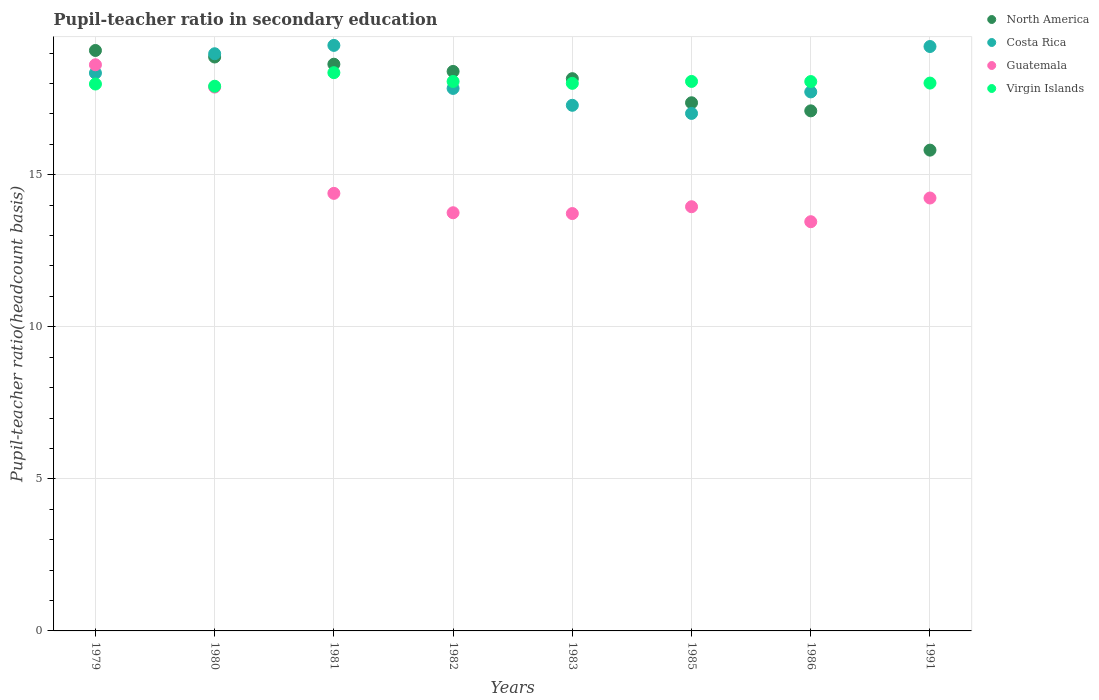Is the number of dotlines equal to the number of legend labels?
Make the answer very short. Yes. What is the pupil-teacher ratio in secondary education in Guatemala in 1979?
Your answer should be compact. 18.62. Across all years, what is the maximum pupil-teacher ratio in secondary education in North America?
Offer a terse response. 19.09. Across all years, what is the minimum pupil-teacher ratio in secondary education in North America?
Provide a succinct answer. 15.81. In which year was the pupil-teacher ratio in secondary education in Virgin Islands maximum?
Keep it short and to the point. 1981. In which year was the pupil-teacher ratio in secondary education in Costa Rica minimum?
Make the answer very short. 1985. What is the total pupil-teacher ratio in secondary education in North America in the graph?
Give a very brief answer. 143.43. What is the difference between the pupil-teacher ratio in secondary education in Guatemala in 1979 and that in 1980?
Your answer should be compact. 0.73. What is the difference between the pupil-teacher ratio in secondary education in Costa Rica in 1983 and the pupil-teacher ratio in secondary education in Guatemala in 1980?
Your answer should be very brief. -0.6. What is the average pupil-teacher ratio in secondary education in North America per year?
Offer a very short reply. 17.93. In the year 1991, what is the difference between the pupil-teacher ratio in secondary education in Virgin Islands and pupil-teacher ratio in secondary education in Guatemala?
Your answer should be very brief. 3.78. In how many years, is the pupil-teacher ratio in secondary education in Costa Rica greater than 10?
Your answer should be compact. 8. What is the ratio of the pupil-teacher ratio in secondary education in Costa Rica in 1980 to that in 1981?
Offer a very short reply. 0.99. Is the difference between the pupil-teacher ratio in secondary education in Virgin Islands in 1980 and 1983 greater than the difference between the pupil-teacher ratio in secondary education in Guatemala in 1980 and 1983?
Keep it short and to the point. No. What is the difference between the highest and the second highest pupil-teacher ratio in secondary education in North America?
Provide a succinct answer. 0.21. What is the difference between the highest and the lowest pupil-teacher ratio in secondary education in Costa Rica?
Give a very brief answer. 2.24. Is the sum of the pupil-teacher ratio in secondary education in Costa Rica in 1981 and 1991 greater than the maximum pupil-teacher ratio in secondary education in North America across all years?
Ensure brevity in your answer.  Yes. Is it the case that in every year, the sum of the pupil-teacher ratio in secondary education in Virgin Islands and pupil-teacher ratio in secondary education in Guatemala  is greater than the sum of pupil-teacher ratio in secondary education in North America and pupil-teacher ratio in secondary education in Costa Rica?
Your answer should be compact. No. Is the pupil-teacher ratio in secondary education in Guatemala strictly less than the pupil-teacher ratio in secondary education in Virgin Islands over the years?
Offer a very short reply. No. Does the graph contain any zero values?
Your response must be concise. No. Does the graph contain grids?
Provide a succinct answer. Yes. Where does the legend appear in the graph?
Make the answer very short. Top right. How are the legend labels stacked?
Provide a short and direct response. Vertical. What is the title of the graph?
Ensure brevity in your answer.  Pupil-teacher ratio in secondary education. Does "Guam" appear as one of the legend labels in the graph?
Keep it short and to the point. No. What is the label or title of the X-axis?
Ensure brevity in your answer.  Years. What is the label or title of the Y-axis?
Provide a short and direct response. Pupil-teacher ratio(headcount basis). What is the Pupil-teacher ratio(headcount basis) of North America in 1979?
Give a very brief answer. 19.09. What is the Pupil-teacher ratio(headcount basis) in Costa Rica in 1979?
Provide a short and direct response. 18.34. What is the Pupil-teacher ratio(headcount basis) of Guatemala in 1979?
Provide a short and direct response. 18.62. What is the Pupil-teacher ratio(headcount basis) of Virgin Islands in 1979?
Provide a short and direct response. 17.98. What is the Pupil-teacher ratio(headcount basis) of North America in 1980?
Provide a succinct answer. 18.87. What is the Pupil-teacher ratio(headcount basis) in Costa Rica in 1980?
Offer a terse response. 18.98. What is the Pupil-teacher ratio(headcount basis) of Guatemala in 1980?
Keep it short and to the point. 17.88. What is the Pupil-teacher ratio(headcount basis) in Virgin Islands in 1980?
Offer a very short reply. 17.91. What is the Pupil-teacher ratio(headcount basis) in North America in 1981?
Your answer should be compact. 18.63. What is the Pupil-teacher ratio(headcount basis) of Costa Rica in 1981?
Your response must be concise. 19.25. What is the Pupil-teacher ratio(headcount basis) of Guatemala in 1981?
Ensure brevity in your answer.  14.39. What is the Pupil-teacher ratio(headcount basis) of Virgin Islands in 1981?
Your response must be concise. 18.36. What is the Pupil-teacher ratio(headcount basis) in North America in 1982?
Give a very brief answer. 18.4. What is the Pupil-teacher ratio(headcount basis) of Costa Rica in 1982?
Provide a short and direct response. 17.84. What is the Pupil-teacher ratio(headcount basis) in Guatemala in 1982?
Your answer should be very brief. 13.75. What is the Pupil-teacher ratio(headcount basis) of Virgin Islands in 1982?
Your answer should be very brief. 18.07. What is the Pupil-teacher ratio(headcount basis) in North America in 1983?
Your answer should be very brief. 18.16. What is the Pupil-teacher ratio(headcount basis) in Costa Rica in 1983?
Offer a terse response. 17.28. What is the Pupil-teacher ratio(headcount basis) in Guatemala in 1983?
Provide a succinct answer. 13.72. What is the Pupil-teacher ratio(headcount basis) in Virgin Islands in 1983?
Offer a terse response. 18.01. What is the Pupil-teacher ratio(headcount basis) in North America in 1985?
Make the answer very short. 17.37. What is the Pupil-teacher ratio(headcount basis) of Costa Rica in 1985?
Your response must be concise. 17.02. What is the Pupil-teacher ratio(headcount basis) of Guatemala in 1985?
Your answer should be compact. 13.95. What is the Pupil-teacher ratio(headcount basis) in Virgin Islands in 1985?
Your response must be concise. 18.07. What is the Pupil-teacher ratio(headcount basis) in North America in 1986?
Ensure brevity in your answer.  17.1. What is the Pupil-teacher ratio(headcount basis) in Costa Rica in 1986?
Offer a very short reply. 17.72. What is the Pupil-teacher ratio(headcount basis) in Guatemala in 1986?
Your answer should be compact. 13.46. What is the Pupil-teacher ratio(headcount basis) of Virgin Islands in 1986?
Provide a short and direct response. 18.06. What is the Pupil-teacher ratio(headcount basis) in North America in 1991?
Keep it short and to the point. 15.81. What is the Pupil-teacher ratio(headcount basis) of Costa Rica in 1991?
Your answer should be compact. 19.22. What is the Pupil-teacher ratio(headcount basis) in Guatemala in 1991?
Provide a succinct answer. 14.24. What is the Pupil-teacher ratio(headcount basis) in Virgin Islands in 1991?
Provide a succinct answer. 18.01. Across all years, what is the maximum Pupil-teacher ratio(headcount basis) in North America?
Provide a succinct answer. 19.09. Across all years, what is the maximum Pupil-teacher ratio(headcount basis) in Costa Rica?
Ensure brevity in your answer.  19.25. Across all years, what is the maximum Pupil-teacher ratio(headcount basis) in Guatemala?
Provide a succinct answer. 18.62. Across all years, what is the maximum Pupil-teacher ratio(headcount basis) of Virgin Islands?
Make the answer very short. 18.36. Across all years, what is the minimum Pupil-teacher ratio(headcount basis) of North America?
Keep it short and to the point. 15.81. Across all years, what is the minimum Pupil-teacher ratio(headcount basis) in Costa Rica?
Keep it short and to the point. 17.02. Across all years, what is the minimum Pupil-teacher ratio(headcount basis) of Guatemala?
Give a very brief answer. 13.46. Across all years, what is the minimum Pupil-teacher ratio(headcount basis) of Virgin Islands?
Keep it short and to the point. 17.91. What is the total Pupil-teacher ratio(headcount basis) of North America in the graph?
Make the answer very short. 143.43. What is the total Pupil-teacher ratio(headcount basis) of Costa Rica in the graph?
Make the answer very short. 145.66. What is the total Pupil-teacher ratio(headcount basis) of Guatemala in the graph?
Offer a terse response. 120. What is the total Pupil-teacher ratio(headcount basis) in Virgin Islands in the graph?
Keep it short and to the point. 144.47. What is the difference between the Pupil-teacher ratio(headcount basis) of North America in 1979 and that in 1980?
Your response must be concise. 0.21. What is the difference between the Pupil-teacher ratio(headcount basis) of Costa Rica in 1979 and that in 1980?
Provide a succinct answer. -0.63. What is the difference between the Pupil-teacher ratio(headcount basis) of Guatemala in 1979 and that in 1980?
Provide a succinct answer. 0.73. What is the difference between the Pupil-teacher ratio(headcount basis) in Virgin Islands in 1979 and that in 1980?
Provide a short and direct response. 0.07. What is the difference between the Pupil-teacher ratio(headcount basis) in North America in 1979 and that in 1981?
Offer a terse response. 0.45. What is the difference between the Pupil-teacher ratio(headcount basis) of Costa Rica in 1979 and that in 1981?
Offer a very short reply. -0.91. What is the difference between the Pupil-teacher ratio(headcount basis) in Guatemala in 1979 and that in 1981?
Keep it short and to the point. 4.23. What is the difference between the Pupil-teacher ratio(headcount basis) of Virgin Islands in 1979 and that in 1981?
Your answer should be very brief. -0.37. What is the difference between the Pupil-teacher ratio(headcount basis) in North America in 1979 and that in 1982?
Your answer should be very brief. 0.69. What is the difference between the Pupil-teacher ratio(headcount basis) of Costa Rica in 1979 and that in 1982?
Your response must be concise. 0.51. What is the difference between the Pupil-teacher ratio(headcount basis) in Guatemala in 1979 and that in 1982?
Keep it short and to the point. 4.87. What is the difference between the Pupil-teacher ratio(headcount basis) in Virgin Islands in 1979 and that in 1982?
Make the answer very short. -0.08. What is the difference between the Pupil-teacher ratio(headcount basis) of North America in 1979 and that in 1983?
Offer a terse response. 0.93. What is the difference between the Pupil-teacher ratio(headcount basis) in Costa Rica in 1979 and that in 1983?
Make the answer very short. 1.06. What is the difference between the Pupil-teacher ratio(headcount basis) of Guatemala in 1979 and that in 1983?
Offer a terse response. 4.89. What is the difference between the Pupil-teacher ratio(headcount basis) of Virgin Islands in 1979 and that in 1983?
Keep it short and to the point. -0.02. What is the difference between the Pupil-teacher ratio(headcount basis) in North America in 1979 and that in 1985?
Your answer should be very brief. 1.72. What is the difference between the Pupil-teacher ratio(headcount basis) of Costa Rica in 1979 and that in 1985?
Give a very brief answer. 1.33. What is the difference between the Pupil-teacher ratio(headcount basis) of Guatemala in 1979 and that in 1985?
Provide a short and direct response. 4.67. What is the difference between the Pupil-teacher ratio(headcount basis) of Virgin Islands in 1979 and that in 1985?
Provide a short and direct response. -0.09. What is the difference between the Pupil-teacher ratio(headcount basis) of North America in 1979 and that in 1986?
Offer a terse response. 1.99. What is the difference between the Pupil-teacher ratio(headcount basis) of Costa Rica in 1979 and that in 1986?
Offer a very short reply. 0.62. What is the difference between the Pupil-teacher ratio(headcount basis) in Guatemala in 1979 and that in 1986?
Provide a succinct answer. 5.16. What is the difference between the Pupil-teacher ratio(headcount basis) in Virgin Islands in 1979 and that in 1986?
Your answer should be very brief. -0.08. What is the difference between the Pupil-teacher ratio(headcount basis) of North America in 1979 and that in 1991?
Ensure brevity in your answer.  3.28. What is the difference between the Pupil-teacher ratio(headcount basis) in Costa Rica in 1979 and that in 1991?
Ensure brevity in your answer.  -0.87. What is the difference between the Pupil-teacher ratio(headcount basis) of Guatemala in 1979 and that in 1991?
Make the answer very short. 4.38. What is the difference between the Pupil-teacher ratio(headcount basis) in Virgin Islands in 1979 and that in 1991?
Your answer should be compact. -0.03. What is the difference between the Pupil-teacher ratio(headcount basis) of North America in 1980 and that in 1981?
Provide a short and direct response. 0.24. What is the difference between the Pupil-teacher ratio(headcount basis) of Costa Rica in 1980 and that in 1981?
Ensure brevity in your answer.  -0.28. What is the difference between the Pupil-teacher ratio(headcount basis) in Guatemala in 1980 and that in 1981?
Your response must be concise. 3.49. What is the difference between the Pupil-teacher ratio(headcount basis) in Virgin Islands in 1980 and that in 1981?
Make the answer very short. -0.45. What is the difference between the Pupil-teacher ratio(headcount basis) in North America in 1980 and that in 1982?
Your answer should be compact. 0.47. What is the difference between the Pupil-teacher ratio(headcount basis) of Costa Rica in 1980 and that in 1982?
Keep it short and to the point. 1.14. What is the difference between the Pupil-teacher ratio(headcount basis) of Guatemala in 1980 and that in 1982?
Make the answer very short. 4.13. What is the difference between the Pupil-teacher ratio(headcount basis) of Virgin Islands in 1980 and that in 1982?
Keep it short and to the point. -0.16. What is the difference between the Pupil-teacher ratio(headcount basis) of North America in 1980 and that in 1983?
Offer a very short reply. 0.71. What is the difference between the Pupil-teacher ratio(headcount basis) in Costa Rica in 1980 and that in 1983?
Make the answer very short. 1.69. What is the difference between the Pupil-teacher ratio(headcount basis) of Guatemala in 1980 and that in 1983?
Your answer should be very brief. 4.16. What is the difference between the Pupil-teacher ratio(headcount basis) in Virgin Islands in 1980 and that in 1983?
Keep it short and to the point. -0.09. What is the difference between the Pupil-teacher ratio(headcount basis) of North America in 1980 and that in 1985?
Make the answer very short. 1.5. What is the difference between the Pupil-teacher ratio(headcount basis) in Costa Rica in 1980 and that in 1985?
Your answer should be very brief. 1.96. What is the difference between the Pupil-teacher ratio(headcount basis) of Guatemala in 1980 and that in 1985?
Your answer should be compact. 3.93. What is the difference between the Pupil-teacher ratio(headcount basis) of Virgin Islands in 1980 and that in 1985?
Give a very brief answer. -0.16. What is the difference between the Pupil-teacher ratio(headcount basis) of North America in 1980 and that in 1986?
Offer a very short reply. 1.77. What is the difference between the Pupil-teacher ratio(headcount basis) in Costa Rica in 1980 and that in 1986?
Keep it short and to the point. 1.25. What is the difference between the Pupil-teacher ratio(headcount basis) of Guatemala in 1980 and that in 1986?
Your answer should be compact. 4.43. What is the difference between the Pupil-teacher ratio(headcount basis) of Virgin Islands in 1980 and that in 1986?
Give a very brief answer. -0.15. What is the difference between the Pupil-teacher ratio(headcount basis) of North America in 1980 and that in 1991?
Offer a terse response. 3.06. What is the difference between the Pupil-teacher ratio(headcount basis) of Costa Rica in 1980 and that in 1991?
Provide a short and direct response. -0.24. What is the difference between the Pupil-teacher ratio(headcount basis) in Guatemala in 1980 and that in 1991?
Your answer should be very brief. 3.65. What is the difference between the Pupil-teacher ratio(headcount basis) in Virgin Islands in 1980 and that in 1991?
Ensure brevity in your answer.  -0.1. What is the difference between the Pupil-teacher ratio(headcount basis) of North America in 1981 and that in 1982?
Provide a succinct answer. 0.24. What is the difference between the Pupil-teacher ratio(headcount basis) of Costa Rica in 1981 and that in 1982?
Give a very brief answer. 1.42. What is the difference between the Pupil-teacher ratio(headcount basis) in Guatemala in 1981 and that in 1982?
Your answer should be compact. 0.64. What is the difference between the Pupil-teacher ratio(headcount basis) in Virgin Islands in 1981 and that in 1982?
Your answer should be compact. 0.29. What is the difference between the Pupil-teacher ratio(headcount basis) in North America in 1981 and that in 1983?
Make the answer very short. 0.48. What is the difference between the Pupil-teacher ratio(headcount basis) in Costa Rica in 1981 and that in 1983?
Your answer should be compact. 1.97. What is the difference between the Pupil-teacher ratio(headcount basis) of Guatemala in 1981 and that in 1983?
Ensure brevity in your answer.  0.66. What is the difference between the Pupil-teacher ratio(headcount basis) in Virgin Islands in 1981 and that in 1983?
Offer a terse response. 0.35. What is the difference between the Pupil-teacher ratio(headcount basis) of North America in 1981 and that in 1985?
Your answer should be compact. 1.27. What is the difference between the Pupil-teacher ratio(headcount basis) of Costa Rica in 1981 and that in 1985?
Keep it short and to the point. 2.24. What is the difference between the Pupil-teacher ratio(headcount basis) in Guatemala in 1981 and that in 1985?
Offer a very short reply. 0.44. What is the difference between the Pupil-teacher ratio(headcount basis) in Virgin Islands in 1981 and that in 1985?
Provide a succinct answer. 0.29. What is the difference between the Pupil-teacher ratio(headcount basis) of North America in 1981 and that in 1986?
Keep it short and to the point. 1.53. What is the difference between the Pupil-teacher ratio(headcount basis) in Costa Rica in 1981 and that in 1986?
Give a very brief answer. 1.53. What is the difference between the Pupil-teacher ratio(headcount basis) of Guatemala in 1981 and that in 1986?
Provide a short and direct response. 0.93. What is the difference between the Pupil-teacher ratio(headcount basis) in Virgin Islands in 1981 and that in 1986?
Keep it short and to the point. 0.29. What is the difference between the Pupil-teacher ratio(headcount basis) of North America in 1981 and that in 1991?
Offer a very short reply. 2.83. What is the difference between the Pupil-teacher ratio(headcount basis) in Costa Rica in 1981 and that in 1991?
Your answer should be very brief. 0.04. What is the difference between the Pupil-teacher ratio(headcount basis) of Guatemala in 1981 and that in 1991?
Make the answer very short. 0.15. What is the difference between the Pupil-teacher ratio(headcount basis) of Virgin Islands in 1981 and that in 1991?
Keep it short and to the point. 0.34. What is the difference between the Pupil-teacher ratio(headcount basis) of North America in 1982 and that in 1983?
Your answer should be very brief. 0.24. What is the difference between the Pupil-teacher ratio(headcount basis) in Costa Rica in 1982 and that in 1983?
Your answer should be compact. 0.55. What is the difference between the Pupil-teacher ratio(headcount basis) of Guatemala in 1982 and that in 1983?
Provide a short and direct response. 0.03. What is the difference between the Pupil-teacher ratio(headcount basis) of Virgin Islands in 1982 and that in 1983?
Offer a terse response. 0.06. What is the difference between the Pupil-teacher ratio(headcount basis) of North America in 1982 and that in 1985?
Make the answer very short. 1.03. What is the difference between the Pupil-teacher ratio(headcount basis) in Costa Rica in 1982 and that in 1985?
Your answer should be compact. 0.82. What is the difference between the Pupil-teacher ratio(headcount basis) of Guatemala in 1982 and that in 1985?
Give a very brief answer. -0.2. What is the difference between the Pupil-teacher ratio(headcount basis) in Virgin Islands in 1982 and that in 1985?
Your answer should be very brief. -0. What is the difference between the Pupil-teacher ratio(headcount basis) of North America in 1982 and that in 1986?
Ensure brevity in your answer.  1.3. What is the difference between the Pupil-teacher ratio(headcount basis) in Costa Rica in 1982 and that in 1986?
Offer a very short reply. 0.11. What is the difference between the Pupil-teacher ratio(headcount basis) of Guatemala in 1982 and that in 1986?
Your answer should be very brief. 0.29. What is the difference between the Pupil-teacher ratio(headcount basis) in Virgin Islands in 1982 and that in 1986?
Keep it short and to the point. 0. What is the difference between the Pupil-teacher ratio(headcount basis) of North America in 1982 and that in 1991?
Ensure brevity in your answer.  2.59. What is the difference between the Pupil-teacher ratio(headcount basis) in Costa Rica in 1982 and that in 1991?
Your response must be concise. -1.38. What is the difference between the Pupil-teacher ratio(headcount basis) in Guatemala in 1982 and that in 1991?
Your answer should be compact. -0.48. What is the difference between the Pupil-teacher ratio(headcount basis) of Virgin Islands in 1982 and that in 1991?
Offer a very short reply. 0.05. What is the difference between the Pupil-teacher ratio(headcount basis) of North America in 1983 and that in 1985?
Provide a short and direct response. 0.79. What is the difference between the Pupil-teacher ratio(headcount basis) in Costa Rica in 1983 and that in 1985?
Keep it short and to the point. 0.27. What is the difference between the Pupil-teacher ratio(headcount basis) in Guatemala in 1983 and that in 1985?
Ensure brevity in your answer.  -0.22. What is the difference between the Pupil-teacher ratio(headcount basis) in Virgin Islands in 1983 and that in 1985?
Keep it short and to the point. -0.06. What is the difference between the Pupil-teacher ratio(headcount basis) of North America in 1983 and that in 1986?
Your response must be concise. 1.06. What is the difference between the Pupil-teacher ratio(headcount basis) in Costa Rica in 1983 and that in 1986?
Your answer should be compact. -0.44. What is the difference between the Pupil-teacher ratio(headcount basis) in Guatemala in 1983 and that in 1986?
Make the answer very short. 0.27. What is the difference between the Pupil-teacher ratio(headcount basis) of Virgin Islands in 1983 and that in 1986?
Your answer should be compact. -0.06. What is the difference between the Pupil-teacher ratio(headcount basis) in North America in 1983 and that in 1991?
Provide a succinct answer. 2.35. What is the difference between the Pupil-teacher ratio(headcount basis) in Costa Rica in 1983 and that in 1991?
Provide a short and direct response. -1.93. What is the difference between the Pupil-teacher ratio(headcount basis) in Guatemala in 1983 and that in 1991?
Offer a terse response. -0.51. What is the difference between the Pupil-teacher ratio(headcount basis) of Virgin Islands in 1983 and that in 1991?
Provide a short and direct response. -0.01. What is the difference between the Pupil-teacher ratio(headcount basis) of North America in 1985 and that in 1986?
Make the answer very short. 0.27. What is the difference between the Pupil-teacher ratio(headcount basis) in Costa Rica in 1985 and that in 1986?
Your response must be concise. -0.71. What is the difference between the Pupil-teacher ratio(headcount basis) of Guatemala in 1985 and that in 1986?
Offer a terse response. 0.49. What is the difference between the Pupil-teacher ratio(headcount basis) in Virgin Islands in 1985 and that in 1986?
Offer a very short reply. 0. What is the difference between the Pupil-teacher ratio(headcount basis) in North America in 1985 and that in 1991?
Make the answer very short. 1.56. What is the difference between the Pupil-teacher ratio(headcount basis) of Costa Rica in 1985 and that in 1991?
Give a very brief answer. -2.2. What is the difference between the Pupil-teacher ratio(headcount basis) in Guatemala in 1985 and that in 1991?
Offer a very short reply. -0.29. What is the difference between the Pupil-teacher ratio(headcount basis) of Virgin Islands in 1985 and that in 1991?
Offer a very short reply. 0.05. What is the difference between the Pupil-teacher ratio(headcount basis) of North America in 1986 and that in 1991?
Ensure brevity in your answer.  1.29. What is the difference between the Pupil-teacher ratio(headcount basis) in Costa Rica in 1986 and that in 1991?
Your answer should be compact. -1.49. What is the difference between the Pupil-teacher ratio(headcount basis) of Guatemala in 1986 and that in 1991?
Your answer should be very brief. -0.78. What is the difference between the Pupil-teacher ratio(headcount basis) of Virgin Islands in 1986 and that in 1991?
Your response must be concise. 0.05. What is the difference between the Pupil-teacher ratio(headcount basis) of North America in 1979 and the Pupil-teacher ratio(headcount basis) of Costa Rica in 1980?
Provide a short and direct response. 0.11. What is the difference between the Pupil-teacher ratio(headcount basis) in North America in 1979 and the Pupil-teacher ratio(headcount basis) in Guatemala in 1980?
Keep it short and to the point. 1.2. What is the difference between the Pupil-teacher ratio(headcount basis) in North America in 1979 and the Pupil-teacher ratio(headcount basis) in Virgin Islands in 1980?
Give a very brief answer. 1.18. What is the difference between the Pupil-teacher ratio(headcount basis) in Costa Rica in 1979 and the Pupil-teacher ratio(headcount basis) in Guatemala in 1980?
Offer a very short reply. 0.46. What is the difference between the Pupil-teacher ratio(headcount basis) of Costa Rica in 1979 and the Pupil-teacher ratio(headcount basis) of Virgin Islands in 1980?
Ensure brevity in your answer.  0.43. What is the difference between the Pupil-teacher ratio(headcount basis) in Guatemala in 1979 and the Pupil-teacher ratio(headcount basis) in Virgin Islands in 1980?
Ensure brevity in your answer.  0.71. What is the difference between the Pupil-teacher ratio(headcount basis) of North America in 1979 and the Pupil-teacher ratio(headcount basis) of Costa Rica in 1981?
Offer a very short reply. -0.17. What is the difference between the Pupil-teacher ratio(headcount basis) of North America in 1979 and the Pupil-teacher ratio(headcount basis) of Guatemala in 1981?
Give a very brief answer. 4.7. What is the difference between the Pupil-teacher ratio(headcount basis) in North America in 1979 and the Pupil-teacher ratio(headcount basis) in Virgin Islands in 1981?
Provide a short and direct response. 0.73. What is the difference between the Pupil-teacher ratio(headcount basis) of Costa Rica in 1979 and the Pupil-teacher ratio(headcount basis) of Guatemala in 1981?
Provide a succinct answer. 3.96. What is the difference between the Pupil-teacher ratio(headcount basis) in Costa Rica in 1979 and the Pupil-teacher ratio(headcount basis) in Virgin Islands in 1981?
Provide a succinct answer. -0.01. What is the difference between the Pupil-teacher ratio(headcount basis) in Guatemala in 1979 and the Pupil-teacher ratio(headcount basis) in Virgin Islands in 1981?
Your answer should be compact. 0.26. What is the difference between the Pupil-teacher ratio(headcount basis) in North America in 1979 and the Pupil-teacher ratio(headcount basis) in Costa Rica in 1982?
Make the answer very short. 1.25. What is the difference between the Pupil-teacher ratio(headcount basis) in North America in 1979 and the Pupil-teacher ratio(headcount basis) in Guatemala in 1982?
Make the answer very short. 5.34. What is the difference between the Pupil-teacher ratio(headcount basis) in Costa Rica in 1979 and the Pupil-teacher ratio(headcount basis) in Guatemala in 1982?
Make the answer very short. 4.59. What is the difference between the Pupil-teacher ratio(headcount basis) of Costa Rica in 1979 and the Pupil-teacher ratio(headcount basis) of Virgin Islands in 1982?
Make the answer very short. 0.28. What is the difference between the Pupil-teacher ratio(headcount basis) of Guatemala in 1979 and the Pupil-teacher ratio(headcount basis) of Virgin Islands in 1982?
Your response must be concise. 0.55. What is the difference between the Pupil-teacher ratio(headcount basis) of North America in 1979 and the Pupil-teacher ratio(headcount basis) of Costa Rica in 1983?
Give a very brief answer. 1.8. What is the difference between the Pupil-teacher ratio(headcount basis) of North America in 1979 and the Pupil-teacher ratio(headcount basis) of Guatemala in 1983?
Your answer should be very brief. 5.36. What is the difference between the Pupil-teacher ratio(headcount basis) of North America in 1979 and the Pupil-teacher ratio(headcount basis) of Virgin Islands in 1983?
Offer a terse response. 1.08. What is the difference between the Pupil-teacher ratio(headcount basis) in Costa Rica in 1979 and the Pupil-teacher ratio(headcount basis) in Guatemala in 1983?
Your answer should be compact. 4.62. What is the difference between the Pupil-teacher ratio(headcount basis) in Costa Rica in 1979 and the Pupil-teacher ratio(headcount basis) in Virgin Islands in 1983?
Offer a very short reply. 0.34. What is the difference between the Pupil-teacher ratio(headcount basis) of Guatemala in 1979 and the Pupil-teacher ratio(headcount basis) of Virgin Islands in 1983?
Offer a terse response. 0.61. What is the difference between the Pupil-teacher ratio(headcount basis) of North America in 1979 and the Pupil-teacher ratio(headcount basis) of Costa Rica in 1985?
Offer a terse response. 2.07. What is the difference between the Pupil-teacher ratio(headcount basis) of North America in 1979 and the Pupil-teacher ratio(headcount basis) of Guatemala in 1985?
Offer a terse response. 5.14. What is the difference between the Pupil-teacher ratio(headcount basis) in North America in 1979 and the Pupil-teacher ratio(headcount basis) in Virgin Islands in 1985?
Your answer should be very brief. 1.02. What is the difference between the Pupil-teacher ratio(headcount basis) of Costa Rica in 1979 and the Pupil-teacher ratio(headcount basis) of Guatemala in 1985?
Provide a succinct answer. 4.4. What is the difference between the Pupil-teacher ratio(headcount basis) in Costa Rica in 1979 and the Pupil-teacher ratio(headcount basis) in Virgin Islands in 1985?
Give a very brief answer. 0.28. What is the difference between the Pupil-teacher ratio(headcount basis) of Guatemala in 1979 and the Pupil-teacher ratio(headcount basis) of Virgin Islands in 1985?
Make the answer very short. 0.55. What is the difference between the Pupil-teacher ratio(headcount basis) of North America in 1979 and the Pupil-teacher ratio(headcount basis) of Costa Rica in 1986?
Your answer should be compact. 1.36. What is the difference between the Pupil-teacher ratio(headcount basis) in North America in 1979 and the Pupil-teacher ratio(headcount basis) in Guatemala in 1986?
Provide a short and direct response. 5.63. What is the difference between the Pupil-teacher ratio(headcount basis) of North America in 1979 and the Pupil-teacher ratio(headcount basis) of Virgin Islands in 1986?
Your answer should be very brief. 1.02. What is the difference between the Pupil-teacher ratio(headcount basis) in Costa Rica in 1979 and the Pupil-teacher ratio(headcount basis) in Guatemala in 1986?
Your response must be concise. 4.89. What is the difference between the Pupil-teacher ratio(headcount basis) in Costa Rica in 1979 and the Pupil-teacher ratio(headcount basis) in Virgin Islands in 1986?
Your answer should be compact. 0.28. What is the difference between the Pupil-teacher ratio(headcount basis) in Guatemala in 1979 and the Pupil-teacher ratio(headcount basis) in Virgin Islands in 1986?
Your answer should be very brief. 0.55. What is the difference between the Pupil-teacher ratio(headcount basis) of North America in 1979 and the Pupil-teacher ratio(headcount basis) of Costa Rica in 1991?
Your response must be concise. -0.13. What is the difference between the Pupil-teacher ratio(headcount basis) of North America in 1979 and the Pupil-teacher ratio(headcount basis) of Guatemala in 1991?
Your answer should be very brief. 4.85. What is the difference between the Pupil-teacher ratio(headcount basis) of North America in 1979 and the Pupil-teacher ratio(headcount basis) of Virgin Islands in 1991?
Ensure brevity in your answer.  1.07. What is the difference between the Pupil-teacher ratio(headcount basis) of Costa Rica in 1979 and the Pupil-teacher ratio(headcount basis) of Guatemala in 1991?
Your answer should be very brief. 4.11. What is the difference between the Pupil-teacher ratio(headcount basis) in Costa Rica in 1979 and the Pupil-teacher ratio(headcount basis) in Virgin Islands in 1991?
Your answer should be very brief. 0.33. What is the difference between the Pupil-teacher ratio(headcount basis) of Guatemala in 1979 and the Pupil-teacher ratio(headcount basis) of Virgin Islands in 1991?
Provide a short and direct response. 0.6. What is the difference between the Pupil-teacher ratio(headcount basis) of North America in 1980 and the Pupil-teacher ratio(headcount basis) of Costa Rica in 1981?
Your response must be concise. -0.38. What is the difference between the Pupil-teacher ratio(headcount basis) in North America in 1980 and the Pupil-teacher ratio(headcount basis) in Guatemala in 1981?
Make the answer very short. 4.48. What is the difference between the Pupil-teacher ratio(headcount basis) of North America in 1980 and the Pupil-teacher ratio(headcount basis) of Virgin Islands in 1981?
Your answer should be compact. 0.52. What is the difference between the Pupil-teacher ratio(headcount basis) of Costa Rica in 1980 and the Pupil-teacher ratio(headcount basis) of Guatemala in 1981?
Offer a very short reply. 4.59. What is the difference between the Pupil-teacher ratio(headcount basis) of Costa Rica in 1980 and the Pupil-teacher ratio(headcount basis) of Virgin Islands in 1981?
Ensure brevity in your answer.  0.62. What is the difference between the Pupil-teacher ratio(headcount basis) of Guatemala in 1980 and the Pupil-teacher ratio(headcount basis) of Virgin Islands in 1981?
Provide a short and direct response. -0.47. What is the difference between the Pupil-teacher ratio(headcount basis) in North America in 1980 and the Pupil-teacher ratio(headcount basis) in Costa Rica in 1982?
Give a very brief answer. 1.03. What is the difference between the Pupil-teacher ratio(headcount basis) in North America in 1980 and the Pupil-teacher ratio(headcount basis) in Guatemala in 1982?
Give a very brief answer. 5.12. What is the difference between the Pupil-teacher ratio(headcount basis) in North America in 1980 and the Pupil-teacher ratio(headcount basis) in Virgin Islands in 1982?
Give a very brief answer. 0.8. What is the difference between the Pupil-teacher ratio(headcount basis) in Costa Rica in 1980 and the Pupil-teacher ratio(headcount basis) in Guatemala in 1982?
Offer a very short reply. 5.23. What is the difference between the Pupil-teacher ratio(headcount basis) in Costa Rica in 1980 and the Pupil-teacher ratio(headcount basis) in Virgin Islands in 1982?
Your answer should be very brief. 0.91. What is the difference between the Pupil-teacher ratio(headcount basis) in Guatemala in 1980 and the Pupil-teacher ratio(headcount basis) in Virgin Islands in 1982?
Your answer should be very brief. -0.19. What is the difference between the Pupil-teacher ratio(headcount basis) of North America in 1980 and the Pupil-teacher ratio(headcount basis) of Costa Rica in 1983?
Keep it short and to the point. 1.59. What is the difference between the Pupil-teacher ratio(headcount basis) of North America in 1980 and the Pupil-teacher ratio(headcount basis) of Guatemala in 1983?
Keep it short and to the point. 5.15. What is the difference between the Pupil-teacher ratio(headcount basis) of North America in 1980 and the Pupil-teacher ratio(headcount basis) of Virgin Islands in 1983?
Make the answer very short. 0.87. What is the difference between the Pupil-teacher ratio(headcount basis) in Costa Rica in 1980 and the Pupil-teacher ratio(headcount basis) in Guatemala in 1983?
Offer a very short reply. 5.25. What is the difference between the Pupil-teacher ratio(headcount basis) in Costa Rica in 1980 and the Pupil-teacher ratio(headcount basis) in Virgin Islands in 1983?
Your answer should be very brief. 0.97. What is the difference between the Pupil-teacher ratio(headcount basis) in Guatemala in 1980 and the Pupil-teacher ratio(headcount basis) in Virgin Islands in 1983?
Your answer should be very brief. -0.12. What is the difference between the Pupil-teacher ratio(headcount basis) of North America in 1980 and the Pupil-teacher ratio(headcount basis) of Costa Rica in 1985?
Your response must be concise. 1.86. What is the difference between the Pupil-teacher ratio(headcount basis) of North America in 1980 and the Pupil-teacher ratio(headcount basis) of Guatemala in 1985?
Ensure brevity in your answer.  4.92. What is the difference between the Pupil-teacher ratio(headcount basis) of North America in 1980 and the Pupil-teacher ratio(headcount basis) of Virgin Islands in 1985?
Give a very brief answer. 0.8. What is the difference between the Pupil-teacher ratio(headcount basis) in Costa Rica in 1980 and the Pupil-teacher ratio(headcount basis) in Guatemala in 1985?
Your answer should be compact. 5.03. What is the difference between the Pupil-teacher ratio(headcount basis) in Costa Rica in 1980 and the Pupil-teacher ratio(headcount basis) in Virgin Islands in 1985?
Provide a short and direct response. 0.91. What is the difference between the Pupil-teacher ratio(headcount basis) of Guatemala in 1980 and the Pupil-teacher ratio(headcount basis) of Virgin Islands in 1985?
Offer a very short reply. -0.19. What is the difference between the Pupil-teacher ratio(headcount basis) of North America in 1980 and the Pupil-teacher ratio(headcount basis) of Costa Rica in 1986?
Offer a very short reply. 1.15. What is the difference between the Pupil-teacher ratio(headcount basis) in North America in 1980 and the Pupil-teacher ratio(headcount basis) in Guatemala in 1986?
Keep it short and to the point. 5.42. What is the difference between the Pupil-teacher ratio(headcount basis) in North America in 1980 and the Pupil-teacher ratio(headcount basis) in Virgin Islands in 1986?
Provide a succinct answer. 0.81. What is the difference between the Pupil-teacher ratio(headcount basis) in Costa Rica in 1980 and the Pupil-teacher ratio(headcount basis) in Guatemala in 1986?
Your answer should be compact. 5.52. What is the difference between the Pupil-teacher ratio(headcount basis) in Costa Rica in 1980 and the Pupil-teacher ratio(headcount basis) in Virgin Islands in 1986?
Provide a short and direct response. 0.91. What is the difference between the Pupil-teacher ratio(headcount basis) in Guatemala in 1980 and the Pupil-teacher ratio(headcount basis) in Virgin Islands in 1986?
Your answer should be very brief. -0.18. What is the difference between the Pupil-teacher ratio(headcount basis) of North America in 1980 and the Pupil-teacher ratio(headcount basis) of Costa Rica in 1991?
Ensure brevity in your answer.  -0.34. What is the difference between the Pupil-teacher ratio(headcount basis) of North America in 1980 and the Pupil-teacher ratio(headcount basis) of Guatemala in 1991?
Give a very brief answer. 4.64. What is the difference between the Pupil-teacher ratio(headcount basis) of North America in 1980 and the Pupil-teacher ratio(headcount basis) of Virgin Islands in 1991?
Your answer should be compact. 0.86. What is the difference between the Pupil-teacher ratio(headcount basis) of Costa Rica in 1980 and the Pupil-teacher ratio(headcount basis) of Guatemala in 1991?
Keep it short and to the point. 4.74. What is the difference between the Pupil-teacher ratio(headcount basis) of Costa Rica in 1980 and the Pupil-teacher ratio(headcount basis) of Virgin Islands in 1991?
Your answer should be very brief. 0.96. What is the difference between the Pupil-teacher ratio(headcount basis) in Guatemala in 1980 and the Pupil-teacher ratio(headcount basis) in Virgin Islands in 1991?
Ensure brevity in your answer.  -0.13. What is the difference between the Pupil-teacher ratio(headcount basis) of North America in 1981 and the Pupil-teacher ratio(headcount basis) of Costa Rica in 1982?
Offer a very short reply. 0.8. What is the difference between the Pupil-teacher ratio(headcount basis) of North America in 1981 and the Pupil-teacher ratio(headcount basis) of Guatemala in 1982?
Make the answer very short. 4.88. What is the difference between the Pupil-teacher ratio(headcount basis) of North America in 1981 and the Pupil-teacher ratio(headcount basis) of Virgin Islands in 1982?
Your response must be concise. 0.57. What is the difference between the Pupil-teacher ratio(headcount basis) of Costa Rica in 1981 and the Pupil-teacher ratio(headcount basis) of Guatemala in 1982?
Your answer should be compact. 5.5. What is the difference between the Pupil-teacher ratio(headcount basis) in Costa Rica in 1981 and the Pupil-teacher ratio(headcount basis) in Virgin Islands in 1982?
Provide a succinct answer. 1.19. What is the difference between the Pupil-teacher ratio(headcount basis) in Guatemala in 1981 and the Pupil-teacher ratio(headcount basis) in Virgin Islands in 1982?
Provide a short and direct response. -3.68. What is the difference between the Pupil-teacher ratio(headcount basis) in North America in 1981 and the Pupil-teacher ratio(headcount basis) in Costa Rica in 1983?
Give a very brief answer. 1.35. What is the difference between the Pupil-teacher ratio(headcount basis) in North America in 1981 and the Pupil-teacher ratio(headcount basis) in Guatemala in 1983?
Offer a very short reply. 4.91. What is the difference between the Pupil-teacher ratio(headcount basis) in North America in 1981 and the Pupil-teacher ratio(headcount basis) in Virgin Islands in 1983?
Provide a short and direct response. 0.63. What is the difference between the Pupil-teacher ratio(headcount basis) of Costa Rica in 1981 and the Pupil-teacher ratio(headcount basis) of Guatemala in 1983?
Offer a terse response. 5.53. What is the difference between the Pupil-teacher ratio(headcount basis) in Costa Rica in 1981 and the Pupil-teacher ratio(headcount basis) in Virgin Islands in 1983?
Your answer should be very brief. 1.25. What is the difference between the Pupil-teacher ratio(headcount basis) in Guatemala in 1981 and the Pupil-teacher ratio(headcount basis) in Virgin Islands in 1983?
Offer a very short reply. -3.62. What is the difference between the Pupil-teacher ratio(headcount basis) in North America in 1981 and the Pupil-teacher ratio(headcount basis) in Costa Rica in 1985?
Offer a terse response. 1.62. What is the difference between the Pupil-teacher ratio(headcount basis) of North America in 1981 and the Pupil-teacher ratio(headcount basis) of Guatemala in 1985?
Make the answer very short. 4.69. What is the difference between the Pupil-teacher ratio(headcount basis) of North America in 1981 and the Pupil-teacher ratio(headcount basis) of Virgin Islands in 1985?
Provide a succinct answer. 0.57. What is the difference between the Pupil-teacher ratio(headcount basis) in Costa Rica in 1981 and the Pupil-teacher ratio(headcount basis) in Guatemala in 1985?
Your response must be concise. 5.31. What is the difference between the Pupil-teacher ratio(headcount basis) of Costa Rica in 1981 and the Pupil-teacher ratio(headcount basis) of Virgin Islands in 1985?
Ensure brevity in your answer.  1.19. What is the difference between the Pupil-teacher ratio(headcount basis) of Guatemala in 1981 and the Pupil-teacher ratio(headcount basis) of Virgin Islands in 1985?
Give a very brief answer. -3.68. What is the difference between the Pupil-teacher ratio(headcount basis) in North America in 1981 and the Pupil-teacher ratio(headcount basis) in Costa Rica in 1986?
Your answer should be very brief. 0.91. What is the difference between the Pupil-teacher ratio(headcount basis) in North America in 1981 and the Pupil-teacher ratio(headcount basis) in Guatemala in 1986?
Provide a succinct answer. 5.18. What is the difference between the Pupil-teacher ratio(headcount basis) in North America in 1981 and the Pupil-teacher ratio(headcount basis) in Virgin Islands in 1986?
Give a very brief answer. 0.57. What is the difference between the Pupil-teacher ratio(headcount basis) of Costa Rica in 1981 and the Pupil-teacher ratio(headcount basis) of Guatemala in 1986?
Keep it short and to the point. 5.8. What is the difference between the Pupil-teacher ratio(headcount basis) in Costa Rica in 1981 and the Pupil-teacher ratio(headcount basis) in Virgin Islands in 1986?
Ensure brevity in your answer.  1.19. What is the difference between the Pupil-teacher ratio(headcount basis) in Guatemala in 1981 and the Pupil-teacher ratio(headcount basis) in Virgin Islands in 1986?
Give a very brief answer. -3.68. What is the difference between the Pupil-teacher ratio(headcount basis) of North America in 1981 and the Pupil-teacher ratio(headcount basis) of Costa Rica in 1991?
Provide a succinct answer. -0.58. What is the difference between the Pupil-teacher ratio(headcount basis) in North America in 1981 and the Pupil-teacher ratio(headcount basis) in Guatemala in 1991?
Your response must be concise. 4.4. What is the difference between the Pupil-teacher ratio(headcount basis) in North America in 1981 and the Pupil-teacher ratio(headcount basis) in Virgin Islands in 1991?
Your answer should be very brief. 0.62. What is the difference between the Pupil-teacher ratio(headcount basis) in Costa Rica in 1981 and the Pupil-teacher ratio(headcount basis) in Guatemala in 1991?
Provide a succinct answer. 5.02. What is the difference between the Pupil-teacher ratio(headcount basis) of Costa Rica in 1981 and the Pupil-teacher ratio(headcount basis) of Virgin Islands in 1991?
Your answer should be very brief. 1.24. What is the difference between the Pupil-teacher ratio(headcount basis) in Guatemala in 1981 and the Pupil-teacher ratio(headcount basis) in Virgin Islands in 1991?
Keep it short and to the point. -3.63. What is the difference between the Pupil-teacher ratio(headcount basis) of North America in 1982 and the Pupil-teacher ratio(headcount basis) of Costa Rica in 1983?
Offer a terse response. 1.11. What is the difference between the Pupil-teacher ratio(headcount basis) of North America in 1982 and the Pupil-teacher ratio(headcount basis) of Guatemala in 1983?
Your answer should be compact. 4.67. What is the difference between the Pupil-teacher ratio(headcount basis) of North America in 1982 and the Pupil-teacher ratio(headcount basis) of Virgin Islands in 1983?
Your answer should be compact. 0.39. What is the difference between the Pupil-teacher ratio(headcount basis) in Costa Rica in 1982 and the Pupil-teacher ratio(headcount basis) in Guatemala in 1983?
Make the answer very short. 4.11. What is the difference between the Pupil-teacher ratio(headcount basis) of Costa Rica in 1982 and the Pupil-teacher ratio(headcount basis) of Virgin Islands in 1983?
Offer a very short reply. -0.17. What is the difference between the Pupil-teacher ratio(headcount basis) of Guatemala in 1982 and the Pupil-teacher ratio(headcount basis) of Virgin Islands in 1983?
Provide a short and direct response. -4.25. What is the difference between the Pupil-teacher ratio(headcount basis) in North America in 1982 and the Pupil-teacher ratio(headcount basis) in Costa Rica in 1985?
Your response must be concise. 1.38. What is the difference between the Pupil-teacher ratio(headcount basis) in North America in 1982 and the Pupil-teacher ratio(headcount basis) in Guatemala in 1985?
Offer a terse response. 4.45. What is the difference between the Pupil-teacher ratio(headcount basis) of North America in 1982 and the Pupil-teacher ratio(headcount basis) of Virgin Islands in 1985?
Your response must be concise. 0.33. What is the difference between the Pupil-teacher ratio(headcount basis) of Costa Rica in 1982 and the Pupil-teacher ratio(headcount basis) of Guatemala in 1985?
Provide a succinct answer. 3.89. What is the difference between the Pupil-teacher ratio(headcount basis) of Costa Rica in 1982 and the Pupil-teacher ratio(headcount basis) of Virgin Islands in 1985?
Ensure brevity in your answer.  -0.23. What is the difference between the Pupil-teacher ratio(headcount basis) in Guatemala in 1982 and the Pupil-teacher ratio(headcount basis) in Virgin Islands in 1985?
Your answer should be compact. -4.32. What is the difference between the Pupil-teacher ratio(headcount basis) in North America in 1982 and the Pupil-teacher ratio(headcount basis) in Costa Rica in 1986?
Your answer should be compact. 0.67. What is the difference between the Pupil-teacher ratio(headcount basis) of North America in 1982 and the Pupil-teacher ratio(headcount basis) of Guatemala in 1986?
Your response must be concise. 4.94. What is the difference between the Pupil-teacher ratio(headcount basis) of North America in 1982 and the Pupil-teacher ratio(headcount basis) of Virgin Islands in 1986?
Your answer should be very brief. 0.33. What is the difference between the Pupil-teacher ratio(headcount basis) of Costa Rica in 1982 and the Pupil-teacher ratio(headcount basis) of Guatemala in 1986?
Ensure brevity in your answer.  4.38. What is the difference between the Pupil-teacher ratio(headcount basis) in Costa Rica in 1982 and the Pupil-teacher ratio(headcount basis) in Virgin Islands in 1986?
Your answer should be very brief. -0.23. What is the difference between the Pupil-teacher ratio(headcount basis) of Guatemala in 1982 and the Pupil-teacher ratio(headcount basis) of Virgin Islands in 1986?
Ensure brevity in your answer.  -4.31. What is the difference between the Pupil-teacher ratio(headcount basis) of North America in 1982 and the Pupil-teacher ratio(headcount basis) of Costa Rica in 1991?
Give a very brief answer. -0.82. What is the difference between the Pupil-teacher ratio(headcount basis) in North America in 1982 and the Pupil-teacher ratio(headcount basis) in Guatemala in 1991?
Keep it short and to the point. 4.16. What is the difference between the Pupil-teacher ratio(headcount basis) of North America in 1982 and the Pupil-teacher ratio(headcount basis) of Virgin Islands in 1991?
Keep it short and to the point. 0.38. What is the difference between the Pupil-teacher ratio(headcount basis) of Costa Rica in 1982 and the Pupil-teacher ratio(headcount basis) of Guatemala in 1991?
Make the answer very short. 3.6. What is the difference between the Pupil-teacher ratio(headcount basis) of Costa Rica in 1982 and the Pupil-teacher ratio(headcount basis) of Virgin Islands in 1991?
Provide a succinct answer. -0.18. What is the difference between the Pupil-teacher ratio(headcount basis) of Guatemala in 1982 and the Pupil-teacher ratio(headcount basis) of Virgin Islands in 1991?
Ensure brevity in your answer.  -4.26. What is the difference between the Pupil-teacher ratio(headcount basis) in North America in 1983 and the Pupil-teacher ratio(headcount basis) in Costa Rica in 1985?
Ensure brevity in your answer.  1.14. What is the difference between the Pupil-teacher ratio(headcount basis) in North America in 1983 and the Pupil-teacher ratio(headcount basis) in Guatemala in 1985?
Make the answer very short. 4.21. What is the difference between the Pupil-teacher ratio(headcount basis) in North America in 1983 and the Pupil-teacher ratio(headcount basis) in Virgin Islands in 1985?
Offer a terse response. 0.09. What is the difference between the Pupil-teacher ratio(headcount basis) in Costa Rica in 1983 and the Pupil-teacher ratio(headcount basis) in Guatemala in 1985?
Offer a very short reply. 3.34. What is the difference between the Pupil-teacher ratio(headcount basis) of Costa Rica in 1983 and the Pupil-teacher ratio(headcount basis) of Virgin Islands in 1985?
Your response must be concise. -0.78. What is the difference between the Pupil-teacher ratio(headcount basis) in Guatemala in 1983 and the Pupil-teacher ratio(headcount basis) in Virgin Islands in 1985?
Give a very brief answer. -4.34. What is the difference between the Pupil-teacher ratio(headcount basis) of North America in 1983 and the Pupil-teacher ratio(headcount basis) of Costa Rica in 1986?
Make the answer very short. 0.44. What is the difference between the Pupil-teacher ratio(headcount basis) of North America in 1983 and the Pupil-teacher ratio(headcount basis) of Guatemala in 1986?
Your response must be concise. 4.7. What is the difference between the Pupil-teacher ratio(headcount basis) of North America in 1983 and the Pupil-teacher ratio(headcount basis) of Virgin Islands in 1986?
Make the answer very short. 0.1. What is the difference between the Pupil-teacher ratio(headcount basis) of Costa Rica in 1983 and the Pupil-teacher ratio(headcount basis) of Guatemala in 1986?
Your response must be concise. 3.83. What is the difference between the Pupil-teacher ratio(headcount basis) of Costa Rica in 1983 and the Pupil-teacher ratio(headcount basis) of Virgin Islands in 1986?
Your response must be concise. -0.78. What is the difference between the Pupil-teacher ratio(headcount basis) of Guatemala in 1983 and the Pupil-teacher ratio(headcount basis) of Virgin Islands in 1986?
Ensure brevity in your answer.  -4.34. What is the difference between the Pupil-teacher ratio(headcount basis) in North America in 1983 and the Pupil-teacher ratio(headcount basis) in Costa Rica in 1991?
Ensure brevity in your answer.  -1.06. What is the difference between the Pupil-teacher ratio(headcount basis) in North America in 1983 and the Pupil-teacher ratio(headcount basis) in Guatemala in 1991?
Your response must be concise. 3.92. What is the difference between the Pupil-teacher ratio(headcount basis) in North America in 1983 and the Pupil-teacher ratio(headcount basis) in Virgin Islands in 1991?
Offer a terse response. 0.14. What is the difference between the Pupil-teacher ratio(headcount basis) of Costa Rica in 1983 and the Pupil-teacher ratio(headcount basis) of Guatemala in 1991?
Your response must be concise. 3.05. What is the difference between the Pupil-teacher ratio(headcount basis) of Costa Rica in 1983 and the Pupil-teacher ratio(headcount basis) of Virgin Islands in 1991?
Your answer should be very brief. -0.73. What is the difference between the Pupil-teacher ratio(headcount basis) of Guatemala in 1983 and the Pupil-teacher ratio(headcount basis) of Virgin Islands in 1991?
Make the answer very short. -4.29. What is the difference between the Pupil-teacher ratio(headcount basis) in North America in 1985 and the Pupil-teacher ratio(headcount basis) in Costa Rica in 1986?
Make the answer very short. -0.36. What is the difference between the Pupil-teacher ratio(headcount basis) of North America in 1985 and the Pupil-teacher ratio(headcount basis) of Guatemala in 1986?
Provide a succinct answer. 3.91. What is the difference between the Pupil-teacher ratio(headcount basis) in North America in 1985 and the Pupil-teacher ratio(headcount basis) in Virgin Islands in 1986?
Your answer should be compact. -0.7. What is the difference between the Pupil-teacher ratio(headcount basis) in Costa Rica in 1985 and the Pupil-teacher ratio(headcount basis) in Guatemala in 1986?
Give a very brief answer. 3.56. What is the difference between the Pupil-teacher ratio(headcount basis) of Costa Rica in 1985 and the Pupil-teacher ratio(headcount basis) of Virgin Islands in 1986?
Your response must be concise. -1.05. What is the difference between the Pupil-teacher ratio(headcount basis) of Guatemala in 1985 and the Pupil-teacher ratio(headcount basis) of Virgin Islands in 1986?
Provide a short and direct response. -4.12. What is the difference between the Pupil-teacher ratio(headcount basis) of North America in 1985 and the Pupil-teacher ratio(headcount basis) of Costa Rica in 1991?
Keep it short and to the point. -1.85. What is the difference between the Pupil-teacher ratio(headcount basis) in North America in 1985 and the Pupil-teacher ratio(headcount basis) in Guatemala in 1991?
Your response must be concise. 3.13. What is the difference between the Pupil-teacher ratio(headcount basis) of North America in 1985 and the Pupil-teacher ratio(headcount basis) of Virgin Islands in 1991?
Keep it short and to the point. -0.65. What is the difference between the Pupil-teacher ratio(headcount basis) in Costa Rica in 1985 and the Pupil-teacher ratio(headcount basis) in Guatemala in 1991?
Your answer should be compact. 2.78. What is the difference between the Pupil-teacher ratio(headcount basis) of Costa Rica in 1985 and the Pupil-teacher ratio(headcount basis) of Virgin Islands in 1991?
Provide a short and direct response. -1. What is the difference between the Pupil-teacher ratio(headcount basis) in Guatemala in 1985 and the Pupil-teacher ratio(headcount basis) in Virgin Islands in 1991?
Offer a very short reply. -4.07. What is the difference between the Pupil-teacher ratio(headcount basis) of North America in 1986 and the Pupil-teacher ratio(headcount basis) of Costa Rica in 1991?
Provide a succinct answer. -2.12. What is the difference between the Pupil-teacher ratio(headcount basis) in North America in 1986 and the Pupil-teacher ratio(headcount basis) in Guatemala in 1991?
Ensure brevity in your answer.  2.87. What is the difference between the Pupil-teacher ratio(headcount basis) in North America in 1986 and the Pupil-teacher ratio(headcount basis) in Virgin Islands in 1991?
Offer a very short reply. -0.91. What is the difference between the Pupil-teacher ratio(headcount basis) of Costa Rica in 1986 and the Pupil-teacher ratio(headcount basis) of Guatemala in 1991?
Provide a succinct answer. 3.49. What is the difference between the Pupil-teacher ratio(headcount basis) in Costa Rica in 1986 and the Pupil-teacher ratio(headcount basis) in Virgin Islands in 1991?
Keep it short and to the point. -0.29. What is the difference between the Pupil-teacher ratio(headcount basis) of Guatemala in 1986 and the Pupil-teacher ratio(headcount basis) of Virgin Islands in 1991?
Ensure brevity in your answer.  -4.56. What is the average Pupil-teacher ratio(headcount basis) of North America per year?
Your answer should be compact. 17.93. What is the average Pupil-teacher ratio(headcount basis) of Costa Rica per year?
Your answer should be very brief. 18.21. What is the average Pupil-teacher ratio(headcount basis) of Virgin Islands per year?
Your answer should be compact. 18.06. In the year 1979, what is the difference between the Pupil-teacher ratio(headcount basis) in North America and Pupil-teacher ratio(headcount basis) in Costa Rica?
Offer a very short reply. 0.74. In the year 1979, what is the difference between the Pupil-teacher ratio(headcount basis) in North America and Pupil-teacher ratio(headcount basis) in Guatemala?
Your response must be concise. 0.47. In the year 1979, what is the difference between the Pupil-teacher ratio(headcount basis) of North America and Pupil-teacher ratio(headcount basis) of Virgin Islands?
Give a very brief answer. 1.1. In the year 1979, what is the difference between the Pupil-teacher ratio(headcount basis) in Costa Rica and Pupil-teacher ratio(headcount basis) in Guatemala?
Provide a succinct answer. -0.27. In the year 1979, what is the difference between the Pupil-teacher ratio(headcount basis) in Costa Rica and Pupil-teacher ratio(headcount basis) in Virgin Islands?
Your answer should be compact. 0.36. In the year 1979, what is the difference between the Pupil-teacher ratio(headcount basis) of Guatemala and Pupil-teacher ratio(headcount basis) of Virgin Islands?
Offer a very short reply. 0.63. In the year 1980, what is the difference between the Pupil-teacher ratio(headcount basis) of North America and Pupil-teacher ratio(headcount basis) of Costa Rica?
Provide a short and direct response. -0.11. In the year 1980, what is the difference between the Pupil-teacher ratio(headcount basis) in North America and Pupil-teacher ratio(headcount basis) in Virgin Islands?
Your answer should be compact. 0.96. In the year 1980, what is the difference between the Pupil-teacher ratio(headcount basis) in Costa Rica and Pupil-teacher ratio(headcount basis) in Guatemala?
Your answer should be compact. 1.1. In the year 1980, what is the difference between the Pupil-teacher ratio(headcount basis) of Costa Rica and Pupil-teacher ratio(headcount basis) of Virgin Islands?
Your response must be concise. 1.07. In the year 1980, what is the difference between the Pupil-teacher ratio(headcount basis) in Guatemala and Pupil-teacher ratio(headcount basis) in Virgin Islands?
Your response must be concise. -0.03. In the year 1981, what is the difference between the Pupil-teacher ratio(headcount basis) of North America and Pupil-teacher ratio(headcount basis) of Costa Rica?
Offer a very short reply. -0.62. In the year 1981, what is the difference between the Pupil-teacher ratio(headcount basis) in North America and Pupil-teacher ratio(headcount basis) in Guatemala?
Make the answer very short. 4.25. In the year 1981, what is the difference between the Pupil-teacher ratio(headcount basis) of North America and Pupil-teacher ratio(headcount basis) of Virgin Islands?
Make the answer very short. 0.28. In the year 1981, what is the difference between the Pupil-teacher ratio(headcount basis) of Costa Rica and Pupil-teacher ratio(headcount basis) of Guatemala?
Your answer should be compact. 4.87. In the year 1981, what is the difference between the Pupil-teacher ratio(headcount basis) of Costa Rica and Pupil-teacher ratio(headcount basis) of Virgin Islands?
Ensure brevity in your answer.  0.9. In the year 1981, what is the difference between the Pupil-teacher ratio(headcount basis) of Guatemala and Pupil-teacher ratio(headcount basis) of Virgin Islands?
Provide a short and direct response. -3.97. In the year 1982, what is the difference between the Pupil-teacher ratio(headcount basis) in North America and Pupil-teacher ratio(headcount basis) in Costa Rica?
Your answer should be very brief. 0.56. In the year 1982, what is the difference between the Pupil-teacher ratio(headcount basis) in North America and Pupil-teacher ratio(headcount basis) in Guatemala?
Your answer should be very brief. 4.65. In the year 1982, what is the difference between the Pupil-teacher ratio(headcount basis) of North America and Pupil-teacher ratio(headcount basis) of Virgin Islands?
Keep it short and to the point. 0.33. In the year 1982, what is the difference between the Pupil-teacher ratio(headcount basis) in Costa Rica and Pupil-teacher ratio(headcount basis) in Guatemala?
Offer a terse response. 4.09. In the year 1982, what is the difference between the Pupil-teacher ratio(headcount basis) in Costa Rica and Pupil-teacher ratio(headcount basis) in Virgin Islands?
Offer a terse response. -0.23. In the year 1982, what is the difference between the Pupil-teacher ratio(headcount basis) of Guatemala and Pupil-teacher ratio(headcount basis) of Virgin Islands?
Your answer should be very brief. -4.32. In the year 1983, what is the difference between the Pupil-teacher ratio(headcount basis) of North America and Pupil-teacher ratio(headcount basis) of Costa Rica?
Give a very brief answer. 0.88. In the year 1983, what is the difference between the Pupil-teacher ratio(headcount basis) in North America and Pupil-teacher ratio(headcount basis) in Guatemala?
Your answer should be compact. 4.44. In the year 1983, what is the difference between the Pupil-teacher ratio(headcount basis) of North America and Pupil-teacher ratio(headcount basis) of Virgin Islands?
Keep it short and to the point. 0.15. In the year 1983, what is the difference between the Pupil-teacher ratio(headcount basis) in Costa Rica and Pupil-teacher ratio(headcount basis) in Guatemala?
Offer a very short reply. 3.56. In the year 1983, what is the difference between the Pupil-teacher ratio(headcount basis) of Costa Rica and Pupil-teacher ratio(headcount basis) of Virgin Islands?
Give a very brief answer. -0.72. In the year 1983, what is the difference between the Pupil-teacher ratio(headcount basis) in Guatemala and Pupil-teacher ratio(headcount basis) in Virgin Islands?
Provide a succinct answer. -4.28. In the year 1985, what is the difference between the Pupil-teacher ratio(headcount basis) in North America and Pupil-teacher ratio(headcount basis) in Costa Rica?
Keep it short and to the point. 0.35. In the year 1985, what is the difference between the Pupil-teacher ratio(headcount basis) of North America and Pupil-teacher ratio(headcount basis) of Guatemala?
Your answer should be compact. 3.42. In the year 1985, what is the difference between the Pupil-teacher ratio(headcount basis) of North America and Pupil-teacher ratio(headcount basis) of Virgin Islands?
Provide a short and direct response. -0.7. In the year 1985, what is the difference between the Pupil-teacher ratio(headcount basis) in Costa Rica and Pupil-teacher ratio(headcount basis) in Guatemala?
Make the answer very short. 3.07. In the year 1985, what is the difference between the Pupil-teacher ratio(headcount basis) in Costa Rica and Pupil-teacher ratio(headcount basis) in Virgin Islands?
Your response must be concise. -1.05. In the year 1985, what is the difference between the Pupil-teacher ratio(headcount basis) in Guatemala and Pupil-teacher ratio(headcount basis) in Virgin Islands?
Provide a short and direct response. -4.12. In the year 1986, what is the difference between the Pupil-teacher ratio(headcount basis) in North America and Pupil-teacher ratio(headcount basis) in Costa Rica?
Your response must be concise. -0.62. In the year 1986, what is the difference between the Pupil-teacher ratio(headcount basis) of North America and Pupil-teacher ratio(headcount basis) of Guatemala?
Provide a succinct answer. 3.65. In the year 1986, what is the difference between the Pupil-teacher ratio(headcount basis) of North America and Pupil-teacher ratio(headcount basis) of Virgin Islands?
Make the answer very short. -0.96. In the year 1986, what is the difference between the Pupil-teacher ratio(headcount basis) of Costa Rica and Pupil-teacher ratio(headcount basis) of Guatemala?
Provide a short and direct response. 4.27. In the year 1986, what is the difference between the Pupil-teacher ratio(headcount basis) of Costa Rica and Pupil-teacher ratio(headcount basis) of Virgin Islands?
Your answer should be very brief. -0.34. In the year 1986, what is the difference between the Pupil-teacher ratio(headcount basis) of Guatemala and Pupil-teacher ratio(headcount basis) of Virgin Islands?
Make the answer very short. -4.61. In the year 1991, what is the difference between the Pupil-teacher ratio(headcount basis) in North America and Pupil-teacher ratio(headcount basis) in Costa Rica?
Offer a terse response. -3.41. In the year 1991, what is the difference between the Pupil-teacher ratio(headcount basis) in North America and Pupil-teacher ratio(headcount basis) in Guatemala?
Your answer should be compact. 1.57. In the year 1991, what is the difference between the Pupil-teacher ratio(headcount basis) in North America and Pupil-teacher ratio(headcount basis) in Virgin Islands?
Make the answer very short. -2.2. In the year 1991, what is the difference between the Pupil-teacher ratio(headcount basis) of Costa Rica and Pupil-teacher ratio(headcount basis) of Guatemala?
Your response must be concise. 4.98. In the year 1991, what is the difference between the Pupil-teacher ratio(headcount basis) in Costa Rica and Pupil-teacher ratio(headcount basis) in Virgin Islands?
Keep it short and to the point. 1.2. In the year 1991, what is the difference between the Pupil-teacher ratio(headcount basis) in Guatemala and Pupil-teacher ratio(headcount basis) in Virgin Islands?
Keep it short and to the point. -3.78. What is the ratio of the Pupil-teacher ratio(headcount basis) in North America in 1979 to that in 1980?
Make the answer very short. 1.01. What is the ratio of the Pupil-teacher ratio(headcount basis) of Costa Rica in 1979 to that in 1980?
Ensure brevity in your answer.  0.97. What is the ratio of the Pupil-teacher ratio(headcount basis) of Guatemala in 1979 to that in 1980?
Provide a succinct answer. 1.04. What is the ratio of the Pupil-teacher ratio(headcount basis) of North America in 1979 to that in 1981?
Ensure brevity in your answer.  1.02. What is the ratio of the Pupil-teacher ratio(headcount basis) in Costa Rica in 1979 to that in 1981?
Give a very brief answer. 0.95. What is the ratio of the Pupil-teacher ratio(headcount basis) in Guatemala in 1979 to that in 1981?
Your answer should be very brief. 1.29. What is the ratio of the Pupil-teacher ratio(headcount basis) in Virgin Islands in 1979 to that in 1981?
Offer a very short reply. 0.98. What is the ratio of the Pupil-teacher ratio(headcount basis) in North America in 1979 to that in 1982?
Your response must be concise. 1.04. What is the ratio of the Pupil-teacher ratio(headcount basis) in Costa Rica in 1979 to that in 1982?
Keep it short and to the point. 1.03. What is the ratio of the Pupil-teacher ratio(headcount basis) in Guatemala in 1979 to that in 1982?
Keep it short and to the point. 1.35. What is the ratio of the Pupil-teacher ratio(headcount basis) of North America in 1979 to that in 1983?
Provide a succinct answer. 1.05. What is the ratio of the Pupil-teacher ratio(headcount basis) of Costa Rica in 1979 to that in 1983?
Give a very brief answer. 1.06. What is the ratio of the Pupil-teacher ratio(headcount basis) in Guatemala in 1979 to that in 1983?
Your answer should be very brief. 1.36. What is the ratio of the Pupil-teacher ratio(headcount basis) of North America in 1979 to that in 1985?
Offer a very short reply. 1.1. What is the ratio of the Pupil-teacher ratio(headcount basis) in Costa Rica in 1979 to that in 1985?
Keep it short and to the point. 1.08. What is the ratio of the Pupil-teacher ratio(headcount basis) in Guatemala in 1979 to that in 1985?
Your answer should be very brief. 1.33. What is the ratio of the Pupil-teacher ratio(headcount basis) in North America in 1979 to that in 1986?
Offer a terse response. 1.12. What is the ratio of the Pupil-teacher ratio(headcount basis) of Costa Rica in 1979 to that in 1986?
Make the answer very short. 1.03. What is the ratio of the Pupil-teacher ratio(headcount basis) of Guatemala in 1979 to that in 1986?
Provide a short and direct response. 1.38. What is the ratio of the Pupil-teacher ratio(headcount basis) in North America in 1979 to that in 1991?
Provide a short and direct response. 1.21. What is the ratio of the Pupil-teacher ratio(headcount basis) in Costa Rica in 1979 to that in 1991?
Offer a very short reply. 0.95. What is the ratio of the Pupil-teacher ratio(headcount basis) in Guatemala in 1979 to that in 1991?
Provide a short and direct response. 1.31. What is the ratio of the Pupil-teacher ratio(headcount basis) in Virgin Islands in 1979 to that in 1991?
Ensure brevity in your answer.  1. What is the ratio of the Pupil-teacher ratio(headcount basis) of North America in 1980 to that in 1981?
Ensure brevity in your answer.  1.01. What is the ratio of the Pupil-teacher ratio(headcount basis) in Costa Rica in 1980 to that in 1981?
Provide a succinct answer. 0.99. What is the ratio of the Pupil-teacher ratio(headcount basis) of Guatemala in 1980 to that in 1981?
Provide a short and direct response. 1.24. What is the ratio of the Pupil-teacher ratio(headcount basis) of Virgin Islands in 1980 to that in 1981?
Ensure brevity in your answer.  0.98. What is the ratio of the Pupil-teacher ratio(headcount basis) in North America in 1980 to that in 1982?
Your answer should be compact. 1.03. What is the ratio of the Pupil-teacher ratio(headcount basis) of Costa Rica in 1980 to that in 1982?
Provide a succinct answer. 1.06. What is the ratio of the Pupil-teacher ratio(headcount basis) of Guatemala in 1980 to that in 1982?
Your answer should be very brief. 1.3. What is the ratio of the Pupil-teacher ratio(headcount basis) in North America in 1980 to that in 1983?
Your answer should be very brief. 1.04. What is the ratio of the Pupil-teacher ratio(headcount basis) of Costa Rica in 1980 to that in 1983?
Make the answer very short. 1.1. What is the ratio of the Pupil-teacher ratio(headcount basis) of Guatemala in 1980 to that in 1983?
Offer a very short reply. 1.3. What is the ratio of the Pupil-teacher ratio(headcount basis) of North America in 1980 to that in 1985?
Your answer should be compact. 1.09. What is the ratio of the Pupil-teacher ratio(headcount basis) of Costa Rica in 1980 to that in 1985?
Offer a terse response. 1.12. What is the ratio of the Pupil-teacher ratio(headcount basis) in Guatemala in 1980 to that in 1985?
Keep it short and to the point. 1.28. What is the ratio of the Pupil-teacher ratio(headcount basis) of North America in 1980 to that in 1986?
Your response must be concise. 1.1. What is the ratio of the Pupil-teacher ratio(headcount basis) of Costa Rica in 1980 to that in 1986?
Provide a succinct answer. 1.07. What is the ratio of the Pupil-teacher ratio(headcount basis) of Guatemala in 1980 to that in 1986?
Give a very brief answer. 1.33. What is the ratio of the Pupil-teacher ratio(headcount basis) of Virgin Islands in 1980 to that in 1986?
Keep it short and to the point. 0.99. What is the ratio of the Pupil-teacher ratio(headcount basis) of North America in 1980 to that in 1991?
Make the answer very short. 1.19. What is the ratio of the Pupil-teacher ratio(headcount basis) of Costa Rica in 1980 to that in 1991?
Your response must be concise. 0.99. What is the ratio of the Pupil-teacher ratio(headcount basis) in Guatemala in 1980 to that in 1991?
Offer a terse response. 1.26. What is the ratio of the Pupil-teacher ratio(headcount basis) in Virgin Islands in 1980 to that in 1991?
Give a very brief answer. 0.99. What is the ratio of the Pupil-teacher ratio(headcount basis) in North America in 1981 to that in 1982?
Your answer should be very brief. 1.01. What is the ratio of the Pupil-teacher ratio(headcount basis) in Costa Rica in 1981 to that in 1982?
Give a very brief answer. 1.08. What is the ratio of the Pupil-teacher ratio(headcount basis) of Guatemala in 1981 to that in 1982?
Offer a terse response. 1.05. What is the ratio of the Pupil-teacher ratio(headcount basis) in Virgin Islands in 1981 to that in 1982?
Make the answer very short. 1.02. What is the ratio of the Pupil-teacher ratio(headcount basis) in North America in 1981 to that in 1983?
Give a very brief answer. 1.03. What is the ratio of the Pupil-teacher ratio(headcount basis) of Costa Rica in 1981 to that in 1983?
Give a very brief answer. 1.11. What is the ratio of the Pupil-teacher ratio(headcount basis) of Guatemala in 1981 to that in 1983?
Provide a short and direct response. 1.05. What is the ratio of the Pupil-teacher ratio(headcount basis) of Virgin Islands in 1981 to that in 1983?
Give a very brief answer. 1.02. What is the ratio of the Pupil-teacher ratio(headcount basis) in North America in 1981 to that in 1985?
Your response must be concise. 1.07. What is the ratio of the Pupil-teacher ratio(headcount basis) of Costa Rica in 1981 to that in 1985?
Keep it short and to the point. 1.13. What is the ratio of the Pupil-teacher ratio(headcount basis) in Guatemala in 1981 to that in 1985?
Make the answer very short. 1.03. What is the ratio of the Pupil-teacher ratio(headcount basis) in Virgin Islands in 1981 to that in 1985?
Offer a terse response. 1.02. What is the ratio of the Pupil-teacher ratio(headcount basis) of North America in 1981 to that in 1986?
Your answer should be very brief. 1.09. What is the ratio of the Pupil-teacher ratio(headcount basis) of Costa Rica in 1981 to that in 1986?
Your answer should be compact. 1.09. What is the ratio of the Pupil-teacher ratio(headcount basis) of Guatemala in 1981 to that in 1986?
Your answer should be very brief. 1.07. What is the ratio of the Pupil-teacher ratio(headcount basis) of Virgin Islands in 1981 to that in 1986?
Make the answer very short. 1.02. What is the ratio of the Pupil-teacher ratio(headcount basis) of North America in 1981 to that in 1991?
Ensure brevity in your answer.  1.18. What is the ratio of the Pupil-teacher ratio(headcount basis) of Guatemala in 1981 to that in 1991?
Your answer should be compact. 1.01. What is the ratio of the Pupil-teacher ratio(headcount basis) in Virgin Islands in 1981 to that in 1991?
Keep it short and to the point. 1.02. What is the ratio of the Pupil-teacher ratio(headcount basis) in North America in 1982 to that in 1983?
Your response must be concise. 1.01. What is the ratio of the Pupil-teacher ratio(headcount basis) of Costa Rica in 1982 to that in 1983?
Provide a succinct answer. 1.03. What is the ratio of the Pupil-teacher ratio(headcount basis) in North America in 1982 to that in 1985?
Provide a short and direct response. 1.06. What is the ratio of the Pupil-teacher ratio(headcount basis) of Costa Rica in 1982 to that in 1985?
Your answer should be very brief. 1.05. What is the ratio of the Pupil-teacher ratio(headcount basis) in Guatemala in 1982 to that in 1985?
Provide a succinct answer. 0.99. What is the ratio of the Pupil-teacher ratio(headcount basis) of Virgin Islands in 1982 to that in 1985?
Your answer should be very brief. 1. What is the ratio of the Pupil-teacher ratio(headcount basis) in North America in 1982 to that in 1986?
Make the answer very short. 1.08. What is the ratio of the Pupil-teacher ratio(headcount basis) in Costa Rica in 1982 to that in 1986?
Offer a very short reply. 1.01. What is the ratio of the Pupil-teacher ratio(headcount basis) in Guatemala in 1982 to that in 1986?
Ensure brevity in your answer.  1.02. What is the ratio of the Pupil-teacher ratio(headcount basis) in North America in 1982 to that in 1991?
Your response must be concise. 1.16. What is the ratio of the Pupil-teacher ratio(headcount basis) in Costa Rica in 1982 to that in 1991?
Make the answer very short. 0.93. What is the ratio of the Pupil-teacher ratio(headcount basis) of Guatemala in 1982 to that in 1991?
Keep it short and to the point. 0.97. What is the ratio of the Pupil-teacher ratio(headcount basis) of North America in 1983 to that in 1985?
Offer a very short reply. 1.05. What is the ratio of the Pupil-teacher ratio(headcount basis) of Costa Rica in 1983 to that in 1985?
Provide a short and direct response. 1.02. What is the ratio of the Pupil-teacher ratio(headcount basis) of Guatemala in 1983 to that in 1985?
Your answer should be very brief. 0.98. What is the ratio of the Pupil-teacher ratio(headcount basis) in Virgin Islands in 1983 to that in 1985?
Give a very brief answer. 1. What is the ratio of the Pupil-teacher ratio(headcount basis) of North America in 1983 to that in 1986?
Ensure brevity in your answer.  1.06. What is the ratio of the Pupil-teacher ratio(headcount basis) of Costa Rica in 1983 to that in 1986?
Your answer should be very brief. 0.98. What is the ratio of the Pupil-teacher ratio(headcount basis) of Guatemala in 1983 to that in 1986?
Ensure brevity in your answer.  1.02. What is the ratio of the Pupil-teacher ratio(headcount basis) in Virgin Islands in 1983 to that in 1986?
Offer a very short reply. 1. What is the ratio of the Pupil-teacher ratio(headcount basis) in North America in 1983 to that in 1991?
Provide a succinct answer. 1.15. What is the ratio of the Pupil-teacher ratio(headcount basis) in Costa Rica in 1983 to that in 1991?
Ensure brevity in your answer.  0.9. What is the ratio of the Pupil-teacher ratio(headcount basis) in Guatemala in 1983 to that in 1991?
Your response must be concise. 0.96. What is the ratio of the Pupil-teacher ratio(headcount basis) in North America in 1985 to that in 1986?
Give a very brief answer. 1.02. What is the ratio of the Pupil-teacher ratio(headcount basis) in Costa Rica in 1985 to that in 1986?
Provide a succinct answer. 0.96. What is the ratio of the Pupil-teacher ratio(headcount basis) of Guatemala in 1985 to that in 1986?
Ensure brevity in your answer.  1.04. What is the ratio of the Pupil-teacher ratio(headcount basis) of North America in 1985 to that in 1991?
Your answer should be compact. 1.1. What is the ratio of the Pupil-teacher ratio(headcount basis) of Costa Rica in 1985 to that in 1991?
Provide a short and direct response. 0.89. What is the ratio of the Pupil-teacher ratio(headcount basis) of Guatemala in 1985 to that in 1991?
Your answer should be compact. 0.98. What is the ratio of the Pupil-teacher ratio(headcount basis) in North America in 1986 to that in 1991?
Keep it short and to the point. 1.08. What is the ratio of the Pupil-teacher ratio(headcount basis) of Costa Rica in 1986 to that in 1991?
Provide a succinct answer. 0.92. What is the ratio of the Pupil-teacher ratio(headcount basis) of Guatemala in 1986 to that in 1991?
Your answer should be very brief. 0.95. What is the ratio of the Pupil-teacher ratio(headcount basis) in Virgin Islands in 1986 to that in 1991?
Offer a very short reply. 1. What is the difference between the highest and the second highest Pupil-teacher ratio(headcount basis) of North America?
Keep it short and to the point. 0.21. What is the difference between the highest and the second highest Pupil-teacher ratio(headcount basis) in Costa Rica?
Offer a very short reply. 0.04. What is the difference between the highest and the second highest Pupil-teacher ratio(headcount basis) in Guatemala?
Provide a short and direct response. 0.73. What is the difference between the highest and the second highest Pupil-teacher ratio(headcount basis) in Virgin Islands?
Give a very brief answer. 0.29. What is the difference between the highest and the lowest Pupil-teacher ratio(headcount basis) in North America?
Keep it short and to the point. 3.28. What is the difference between the highest and the lowest Pupil-teacher ratio(headcount basis) of Costa Rica?
Ensure brevity in your answer.  2.24. What is the difference between the highest and the lowest Pupil-teacher ratio(headcount basis) in Guatemala?
Your answer should be very brief. 5.16. What is the difference between the highest and the lowest Pupil-teacher ratio(headcount basis) in Virgin Islands?
Keep it short and to the point. 0.45. 